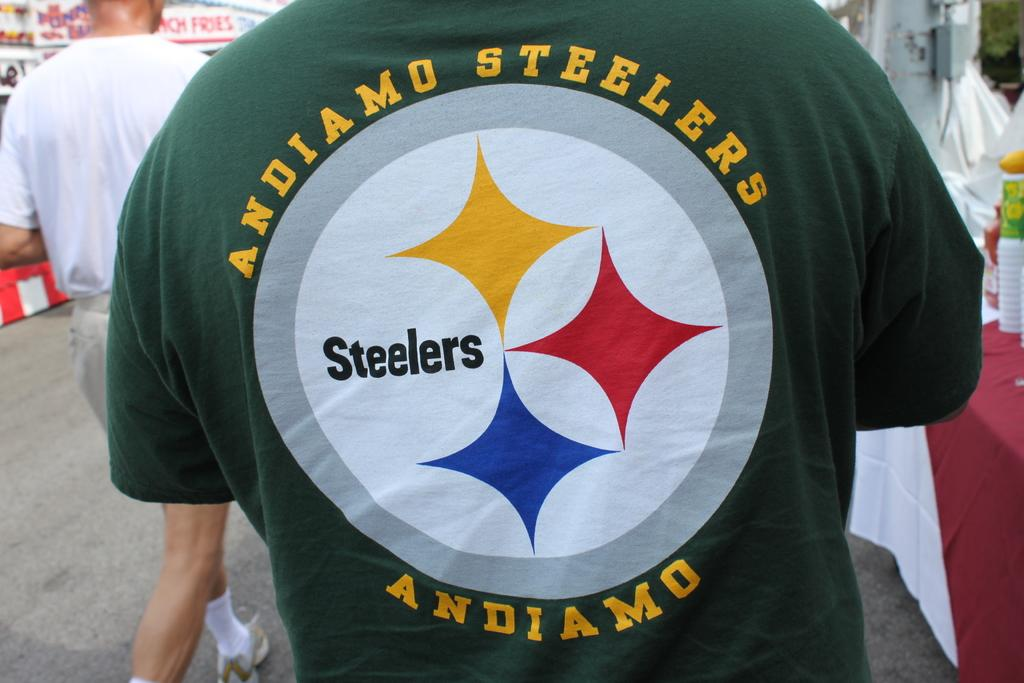<image>
Relay a brief, clear account of the picture shown. a Steelers shirt on the back of a man outdoors 